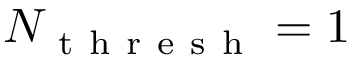<formula> <loc_0><loc_0><loc_500><loc_500>N _ { t h r e s h } = 1</formula> 